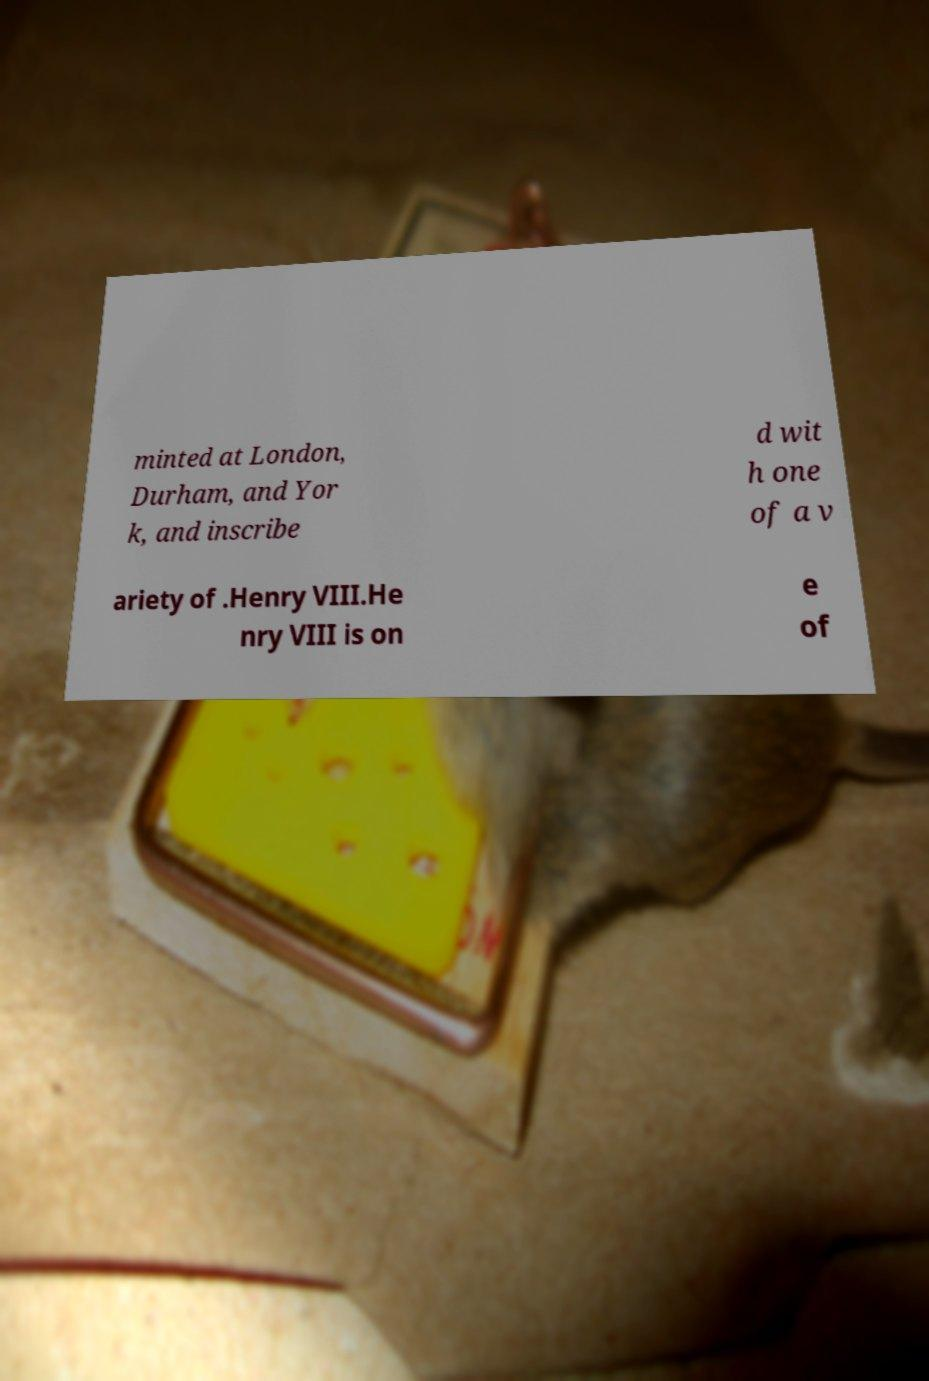There's text embedded in this image that I need extracted. Can you transcribe it verbatim? minted at London, Durham, and Yor k, and inscribe d wit h one of a v ariety of .Henry VIII.He nry VIII is on e of 